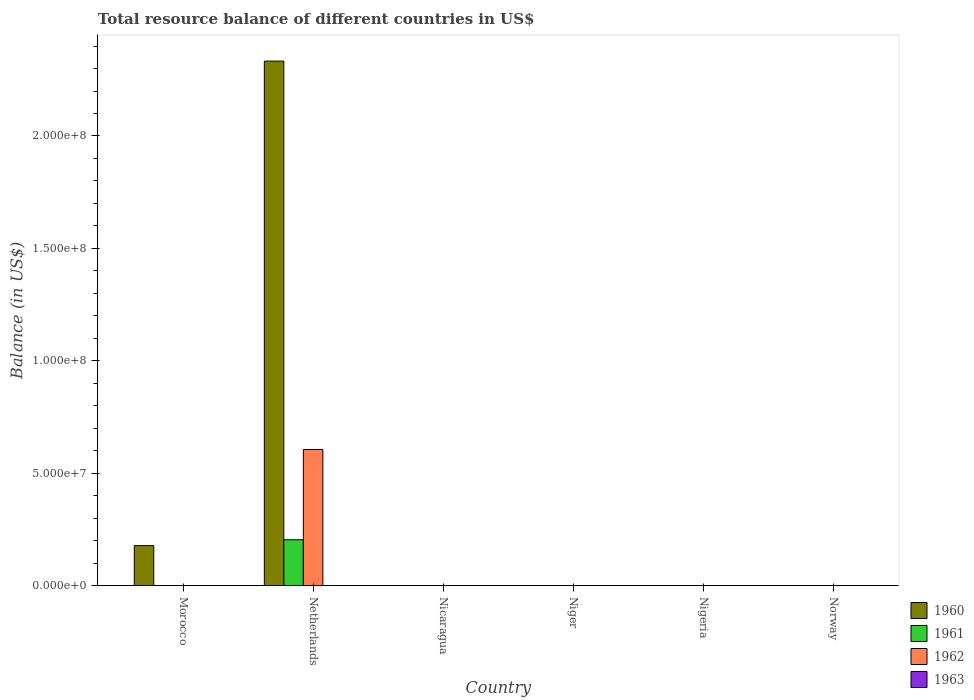Are the number of bars per tick equal to the number of legend labels?
Your response must be concise. No. Are the number of bars on each tick of the X-axis equal?
Provide a succinct answer. No. In how many cases, is the number of bars for a given country not equal to the number of legend labels?
Offer a terse response. 6. Across all countries, what is the maximum total resource balance in 1962?
Offer a terse response. 6.05e+07. What is the total total resource balance in 1960 in the graph?
Your answer should be very brief. 2.51e+08. What is the difference between the total resource balance in 1963 in Norway and the total resource balance in 1961 in Netherlands?
Offer a very short reply. -2.04e+07. What is the average total resource balance in 1961 per country?
Offer a very short reply. 3.40e+06. What is the difference between the total resource balance of/in 1961 and total resource balance of/in 1962 in Netherlands?
Offer a very short reply. -4.01e+07. What is the difference between the highest and the lowest total resource balance in 1961?
Ensure brevity in your answer.  2.04e+07. How many bars are there?
Offer a terse response. 4. What is the difference between two consecutive major ticks on the Y-axis?
Offer a terse response. 5.00e+07. Does the graph contain any zero values?
Your response must be concise. Yes. Where does the legend appear in the graph?
Your response must be concise. Bottom right. How are the legend labels stacked?
Your response must be concise. Vertical. What is the title of the graph?
Your answer should be compact. Total resource balance of different countries in US$. Does "1985" appear as one of the legend labels in the graph?
Your response must be concise. No. What is the label or title of the X-axis?
Your answer should be very brief. Country. What is the label or title of the Y-axis?
Provide a succinct answer. Balance (in US$). What is the Balance (in US$) in 1960 in Morocco?
Keep it short and to the point. 1.78e+07. What is the Balance (in US$) of 1961 in Morocco?
Offer a terse response. 0. What is the Balance (in US$) of 1962 in Morocco?
Your response must be concise. 0. What is the Balance (in US$) in 1963 in Morocco?
Your answer should be very brief. 0. What is the Balance (in US$) of 1960 in Netherlands?
Your answer should be very brief. 2.33e+08. What is the Balance (in US$) of 1961 in Netherlands?
Offer a very short reply. 2.04e+07. What is the Balance (in US$) in 1962 in Netherlands?
Your answer should be compact. 6.05e+07. What is the Balance (in US$) in 1961 in Nicaragua?
Make the answer very short. 0. What is the Balance (in US$) of 1962 in Nicaragua?
Give a very brief answer. 0. What is the Balance (in US$) in 1963 in Nicaragua?
Provide a succinct answer. 0. What is the Balance (in US$) in 1961 in Niger?
Your answer should be compact. 0. What is the Balance (in US$) of 1963 in Niger?
Provide a succinct answer. 0. What is the Balance (in US$) in 1961 in Nigeria?
Your answer should be compact. 0. What is the Balance (in US$) in 1963 in Nigeria?
Keep it short and to the point. 0. What is the Balance (in US$) in 1963 in Norway?
Make the answer very short. 0. Across all countries, what is the maximum Balance (in US$) of 1960?
Keep it short and to the point. 2.33e+08. Across all countries, what is the maximum Balance (in US$) in 1961?
Ensure brevity in your answer.  2.04e+07. Across all countries, what is the maximum Balance (in US$) of 1962?
Keep it short and to the point. 6.05e+07. Across all countries, what is the minimum Balance (in US$) of 1960?
Your answer should be very brief. 0. Across all countries, what is the minimum Balance (in US$) of 1961?
Keep it short and to the point. 0. Across all countries, what is the minimum Balance (in US$) of 1962?
Offer a terse response. 0. What is the total Balance (in US$) in 1960 in the graph?
Offer a very short reply. 2.51e+08. What is the total Balance (in US$) in 1961 in the graph?
Your answer should be very brief. 2.04e+07. What is the total Balance (in US$) of 1962 in the graph?
Your response must be concise. 6.05e+07. What is the difference between the Balance (in US$) in 1960 in Morocco and that in Netherlands?
Provide a short and direct response. -2.16e+08. What is the difference between the Balance (in US$) of 1960 in Morocco and the Balance (in US$) of 1961 in Netherlands?
Offer a very short reply. -2.59e+06. What is the difference between the Balance (in US$) of 1960 in Morocco and the Balance (in US$) of 1962 in Netherlands?
Provide a succinct answer. -4.27e+07. What is the average Balance (in US$) of 1960 per country?
Your answer should be very brief. 4.18e+07. What is the average Balance (in US$) in 1961 per country?
Give a very brief answer. 3.40e+06. What is the average Balance (in US$) of 1962 per country?
Offer a terse response. 1.01e+07. What is the difference between the Balance (in US$) of 1960 and Balance (in US$) of 1961 in Netherlands?
Provide a short and direct response. 2.13e+08. What is the difference between the Balance (in US$) of 1960 and Balance (in US$) of 1962 in Netherlands?
Ensure brevity in your answer.  1.73e+08. What is the difference between the Balance (in US$) of 1961 and Balance (in US$) of 1962 in Netherlands?
Ensure brevity in your answer.  -4.01e+07. What is the ratio of the Balance (in US$) of 1960 in Morocco to that in Netherlands?
Provide a succinct answer. 0.08. What is the difference between the highest and the lowest Balance (in US$) in 1960?
Ensure brevity in your answer.  2.33e+08. What is the difference between the highest and the lowest Balance (in US$) of 1961?
Keep it short and to the point. 2.04e+07. What is the difference between the highest and the lowest Balance (in US$) of 1962?
Provide a succinct answer. 6.05e+07. 